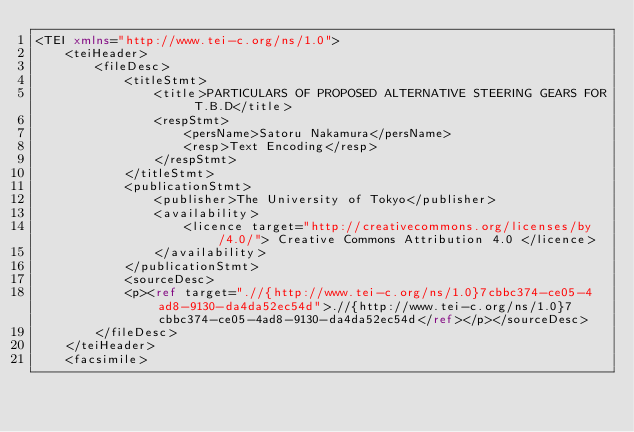<code> <loc_0><loc_0><loc_500><loc_500><_XML_><TEI xmlns="http://www.tei-c.org/ns/1.0">
    <teiHeader>
        <fileDesc>
            <titleStmt>
                <title>PARTICULARS OF PROPOSED ALTERNATIVE STEERING GEARS FOR T.B.D</title>
                <respStmt>
                    <persName>Satoru Nakamura</persName>
                    <resp>Text Encoding</resp>
                </respStmt>
            </titleStmt>
            <publicationStmt>
                <publisher>The University of Tokyo</publisher>
                <availability>
                    <licence target="http://creativecommons.org/licenses/by/4.0/"> Creative Commons Attribution 4.0 </licence>
                </availability>
            </publicationStmt>
            <sourceDesc>
            <p><ref target=".//{http://www.tei-c.org/ns/1.0}7cbbc374-ce05-4ad8-9130-da4da52ec54d">.//{http://www.tei-c.org/ns/1.0}7cbbc374-ce05-4ad8-9130-da4da52ec54d</ref></p></sourceDesc>
        </fileDesc>
    </teiHeader>
    <facsimile></code> 